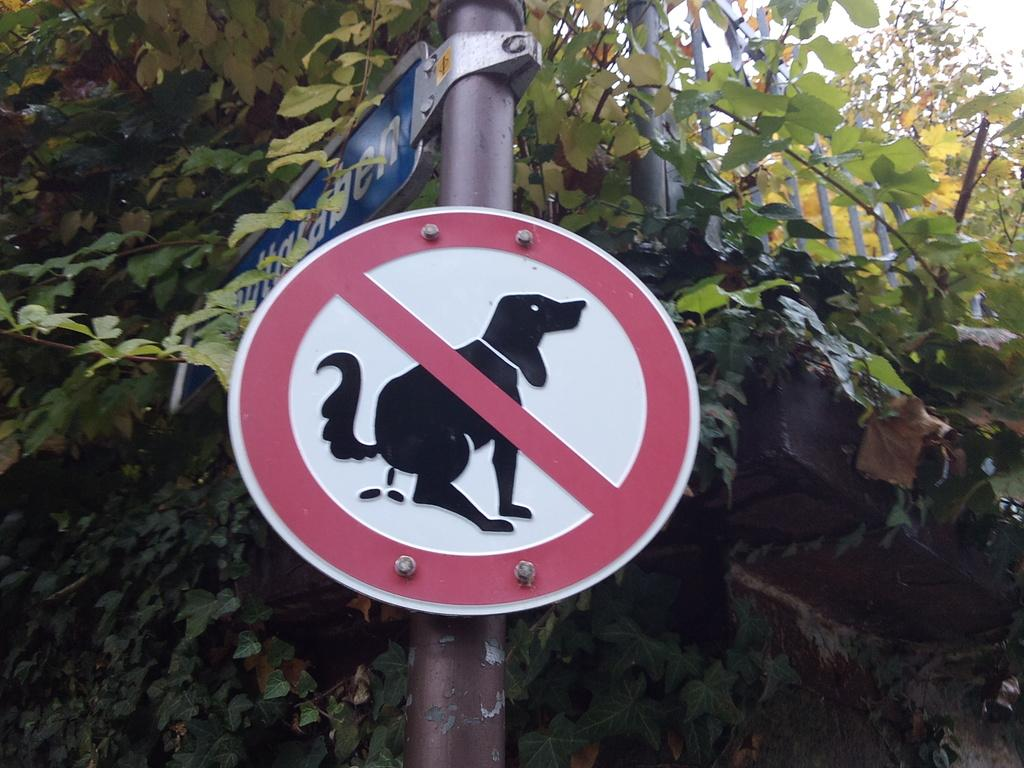What is attached to the pole in the image? There are boards on a pole in the image. What type of vegetation can be seen in the image? There are leaves visible in the image. What type of barrier is present in the image? There is a fence in the image. What is visible in the background of the image? The sky is visible in the background of the image. Can you see the ocean in the image? No, there is no ocean visible in the image. Is there a dog interacting with the fence in the image? No, there is no dog present in the image. 